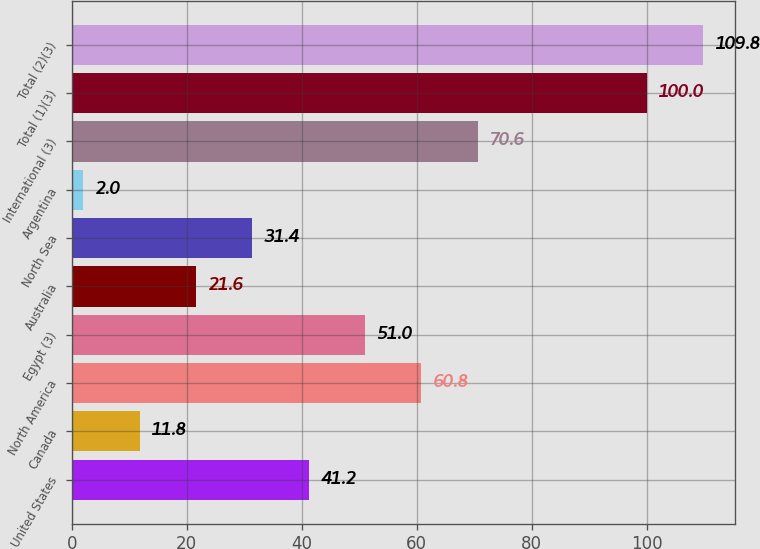Convert chart. <chart><loc_0><loc_0><loc_500><loc_500><bar_chart><fcel>United States<fcel>Canada<fcel>North America<fcel>Egypt (3)<fcel>Australia<fcel>North Sea<fcel>Argentina<fcel>International (3)<fcel>Total (1)(3)<fcel>Total (2)(3)<nl><fcel>41.2<fcel>11.8<fcel>60.8<fcel>51<fcel>21.6<fcel>31.4<fcel>2<fcel>70.6<fcel>100<fcel>109.8<nl></chart> 